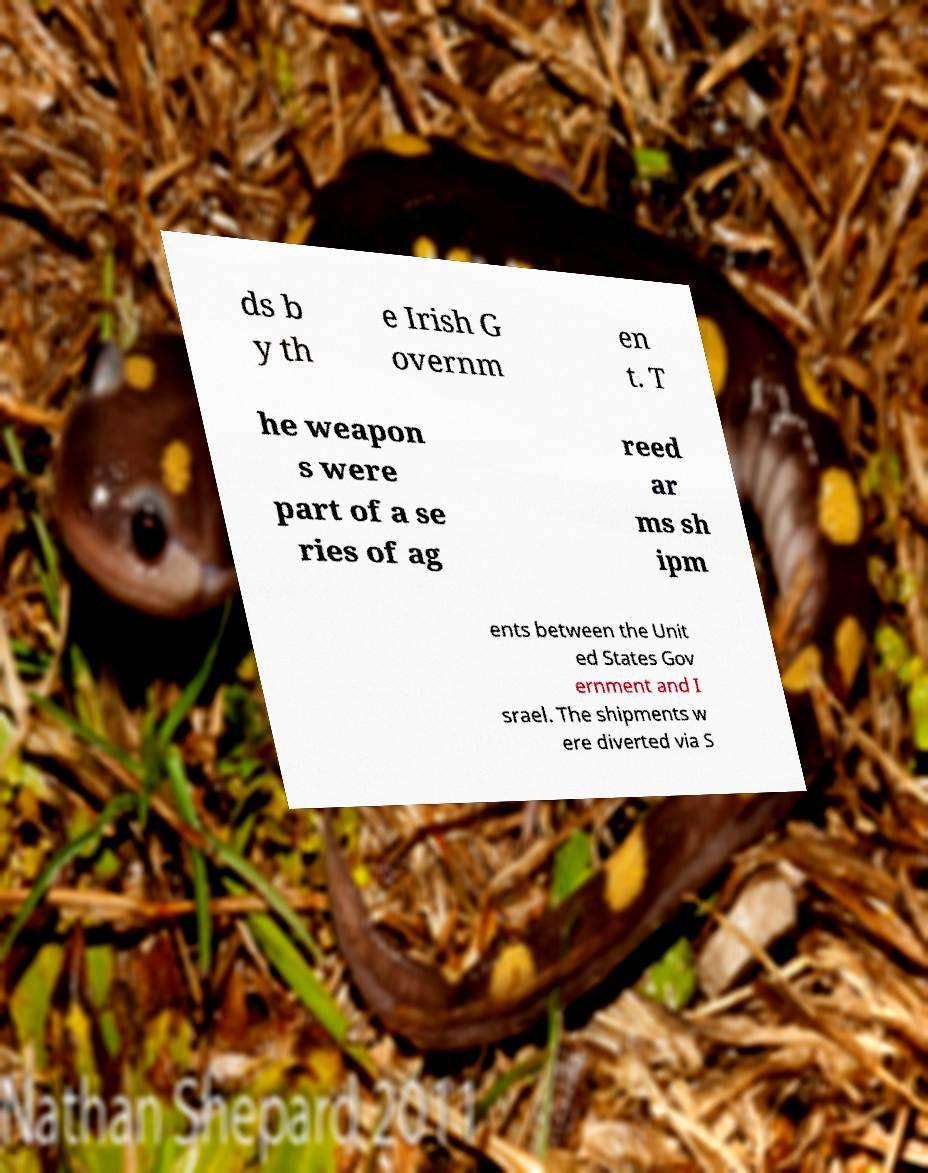Please identify and transcribe the text found in this image. ds b y th e Irish G overnm en t. T he weapon s were part of a se ries of ag reed ar ms sh ipm ents between the Unit ed States Gov ernment and I srael. The shipments w ere diverted via S 